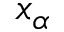<formula> <loc_0><loc_0><loc_500><loc_500>x _ { \alpha }</formula> 